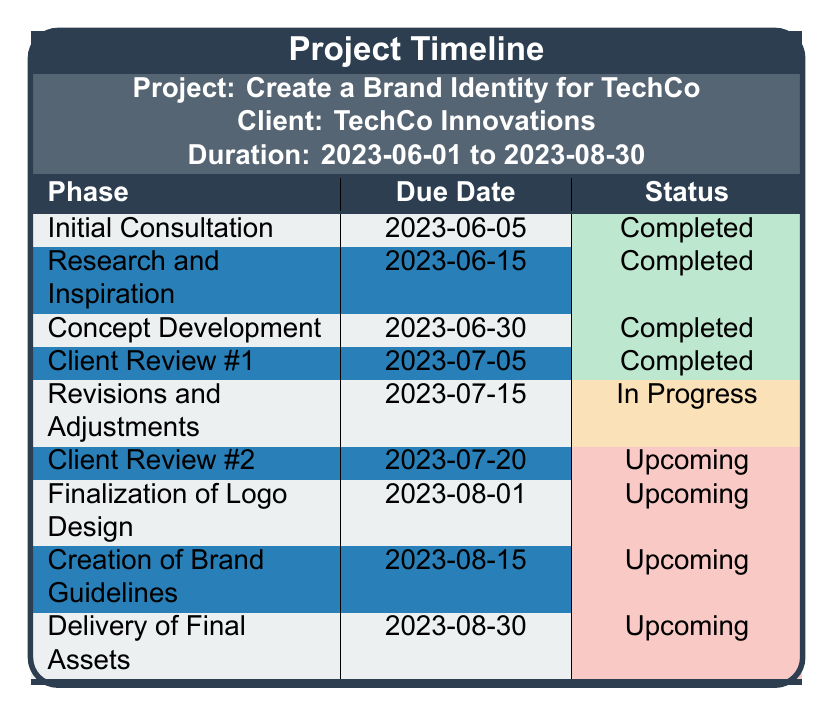What is the due date for the "Client Review #1" phase? The table lists the due dates for each phase, and "Client Review #1" has a due date of "2023-07-05".
Answer: 2023-07-05 How many phases are completed as of now? The "Status" column indicates which phases are completed. Four phases are marked as "Completed": "Initial Consultation", "Research and Inspiration", "Concept Development", and "Client Review #1".
Answer: 4 What is the status of the phase "Finalization of Logo Design"? Looking at the status column for the phase "Finalization of Logo Design", it is listed as "Upcoming".
Answer: Upcoming Which phase is currently in progress and what is its due date? The only phase marked as "In Progress" is "Revisions and Adjustments" with a due date of "2023-07-15".
Answer: Revisions and Adjustments, 2023-07-15 What is the total number of milestones planned for this project? Counting the milestones listed in the table, there are a total of nine phases outlined for this project.
Answer: 9 Is there any phase that has a due date before today's date (assuming today's date is in August 2023)? The table shows several completed phases with due dates before today's date. For example, "Initial Consultation" due on "2023-06-05".
Answer: Yes What is the next upcoming phase after "Revisions and Adjustments"? The phase following "Revisions and Adjustments" is "Client Review #2", which has a due date of "2023-07-20".
Answer: Client Review #2, 2023-07-20 How many phases are set to be completed after August 1, 2023? The phases "Creation of Brand Guidelines" and "Delivery of Final Assets" have due dates after August 1, 2023. Therefore, there are two upcoming milestones after this date.
Answer: 2 What percentage of the project milestones have been completed? There are 4 completed phases out of 9 total phases. The percentage is (4/9) * 100 = 44.44%.
Answer: 44.44% If a delay occurs in "Client Review #2", how might that affect subsequent milestones? If "Client Review #2", scheduled for "2023-07-20", is delayed, it could push back "Finalization of Logo Design" (due on "2023-08-01") and consequently, "Creation of Brand Guidelines" and "Delivery of Final Assets" might also be delayed.
Answer: Timeline may shift 